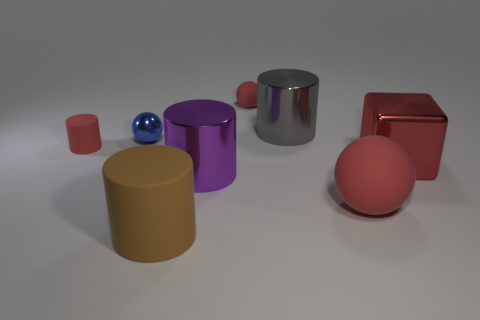Subtract all red cylinders. How many cylinders are left? 3 Subtract all purple blocks. How many red balls are left? 2 Add 2 blue spheres. How many objects exist? 10 Subtract all spheres. How many objects are left? 5 Subtract all gray cylinders. How many cylinders are left? 3 Subtract 2 cylinders. How many cylinders are left? 2 Subtract all blue cubes. Subtract all yellow spheres. How many cubes are left? 1 Subtract all matte things. Subtract all brown things. How many objects are left? 3 Add 1 matte things. How many matte things are left? 5 Add 8 large yellow shiny balls. How many large yellow shiny balls exist? 8 